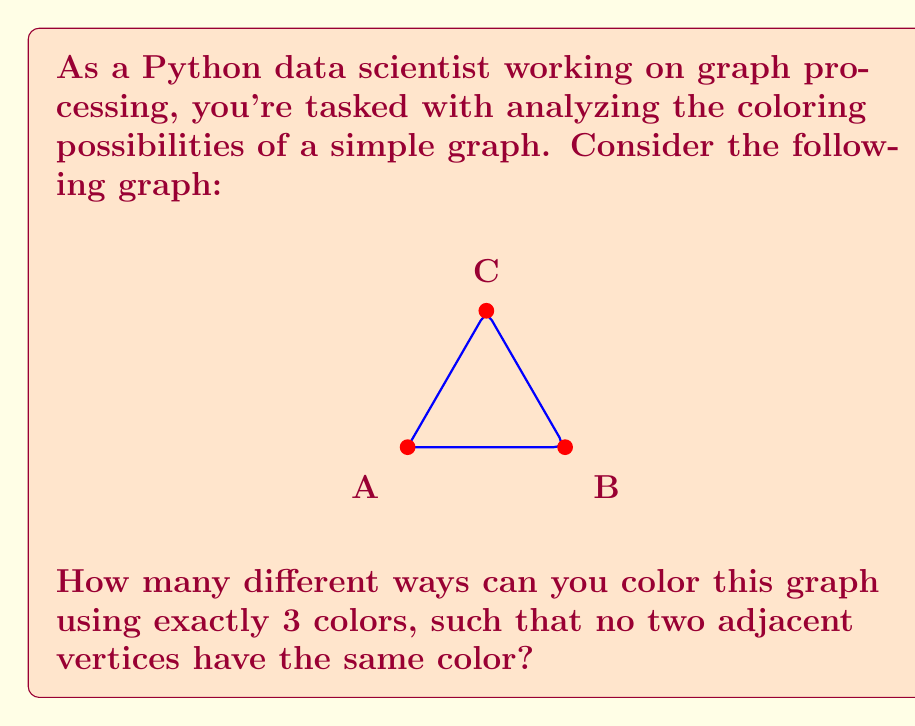What is the answer to this math problem? Let's approach this step-by-step:

1) First, we need to understand what constitutes a valid coloring. In this case, each vertex must be colored, and no two adjacent vertices can have the same color.

2) We have 3 colors available, let's call them 1, 2, and 3.

3) For the first vertex (let's say A), we have 3 choices, as we can use any of the three colors.

4) For the second vertex (B), we can't use the color we used for A, so we have 2 choices.

5) For the third vertex (C), we can't use the color we used for A or B, so we have only 1 choice left.

6) This might lead us to think the answer is $3 * 2 * 1 = 6$, but we need to consider all possible starting points.

7) We can start with any of the three vertices, and each starting point will give us 6 colorings.

8) However, this counts each unique coloring 3 times (once for each starting vertex), so we need to divide by 3.

9) Therefore, the total number of unique colorings is:

   $$ \frac{3 * 6}{3} = 6 $$

This result can also be derived from the chromatic polynomial of the graph, which for a 3-cycle is $x(x-1)(x-2)$, where $x$ is the number of colors. Plugging in 3 for $x$ gives us 6.
Answer: 6 